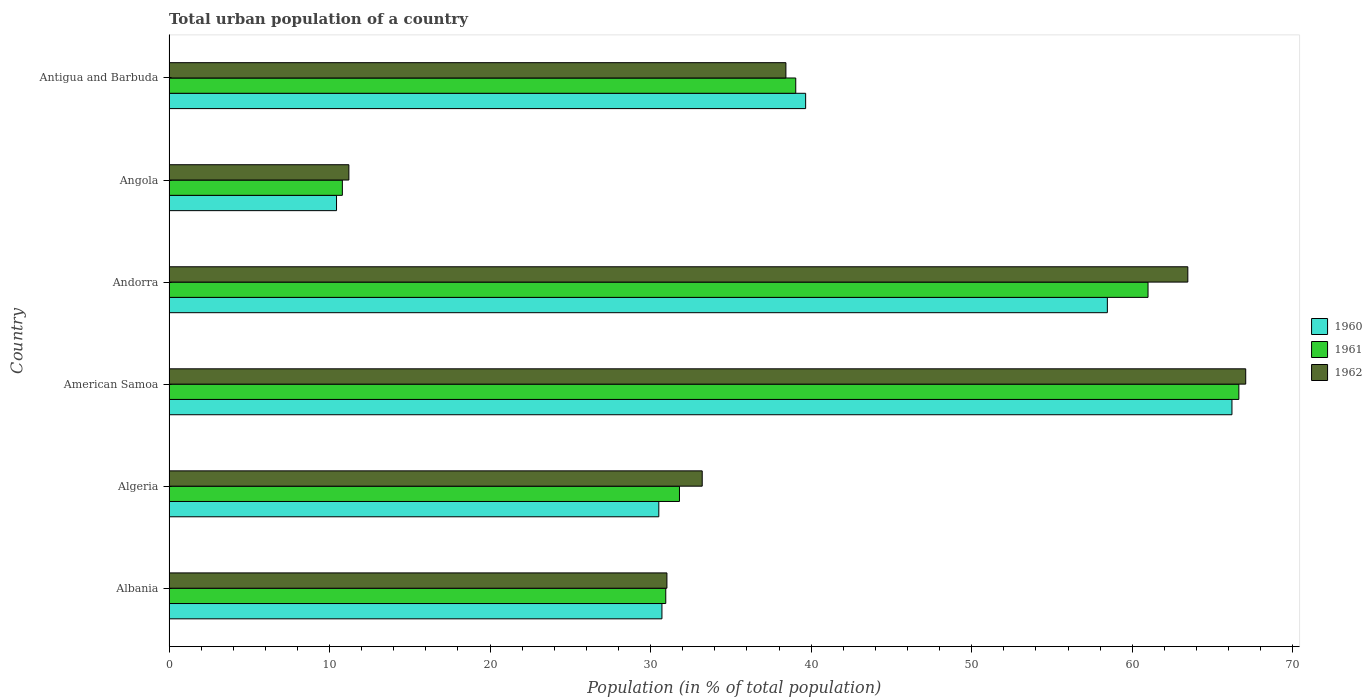How many groups of bars are there?
Provide a succinct answer. 6. Are the number of bars per tick equal to the number of legend labels?
Make the answer very short. Yes. Are the number of bars on each tick of the Y-axis equal?
Give a very brief answer. Yes. How many bars are there on the 6th tick from the top?
Keep it short and to the point. 3. How many bars are there on the 5th tick from the bottom?
Your answer should be very brief. 3. What is the label of the 6th group of bars from the top?
Give a very brief answer. Albania. What is the urban population in 1962 in Albania?
Offer a very short reply. 31.02. Across all countries, what is the maximum urban population in 1960?
Your answer should be compact. 66.21. Across all countries, what is the minimum urban population in 1960?
Offer a terse response. 10.44. In which country was the urban population in 1960 maximum?
Ensure brevity in your answer.  American Samoa. In which country was the urban population in 1962 minimum?
Give a very brief answer. Angola. What is the total urban population in 1961 in the graph?
Offer a very short reply. 240.2. What is the difference between the urban population in 1961 in Algeria and that in Andorra?
Give a very brief answer. -29.19. What is the difference between the urban population in 1960 in Antigua and Barbuda and the urban population in 1961 in Angola?
Make the answer very short. 28.86. What is the average urban population in 1962 per country?
Offer a very short reply. 40.73. What is the difference between the urban population in 1961 and urban population in 1960 in American Samoa?
Give a very brief answer. 0.43. In how many countries, is the urban population in 1960 greater than 54 %?
Your response must be concise. 2. What is the ratio of the urban population in 1960 in Albania to that in Andorra?
Make the answer very short. 0.53. What is the difference between the highest and the second highest urban population in 1962?
Your answer should be very brief. 3.61. What is the difference between the highest and the lowest urban population in 1960?
Make the answer very short. 55.78. In how many countries, is the urban population in 1962 greater than the average urban population in 1962 taken over all countries?
Provide a short and direct response. 2. What does the 1st bar from the bottom in American Samoa represents?
Give a very brief answer. 1960. How many countries are there in the graph?
Keep it short and to the point. 6. Does the graph contain grids?
Ensure brevity in your answer.  No. What is the title of the graph?
Give a very brief answer. Total urban population of a country. Does "1988" appear as one of the legend labels in the graph?
Offer a very short reply. No. What is the label or title of the X-axis?
Keep it short and to the point. Population (in % of total population). What is the Population (in % of total population) of 1960 in Albania?
Your response must be concise. 30.7. What is the Population (in % of total population) of 1961 in Albania?
Give a very brief answer. 30.94. What is the Population (in % of total population) of 1962 in Albania?
Provide a succinct answer. 31.02. What is the Population (in % of total population) in 1960 in Algeria?
Your response must be concise. 30.51. What is the Population (in % of total population) of 1961 in Algeria?
Offer a very short reply. 31.8. What is the Population (in % of total population) in 1962 in Algeria?
Your response must be concise. 33.21. What is the Population (in % of total population) of 1960 in American Samoa?
Your answer should be very brief. 66.21. What is the Population (in % of total population) of 1961 in American Samoa?
Offer a terse response. 66.64. What is the Population (in % of total population) in 1962 in American Samoa?
Provide a short and direct response. 67.07. What is the Population (in % of total population) in 1960 in Andorra?
Your response must be concise. 58.45. What is the Population (in % of total population) of 1961 in Andorra?
Your answer should be compact. 60.98. What is the Population (in % of total population) in 1962 in Andorra?
Give a very brief answer. 63.46. What is the Population (in % of total population) in 1960 in Angola?
Provide a short and direct response. 10.44. What is the Population (in % of total population) in 1961 in Angola?
Keep it short and to the point. 10.8. What is the Population (in % of total population) of 1962 in Angola?
Offer a terse response. 11.2. What is the Population (in % of total population) in 1960 in Antigua and Barbuda?
Your answer should be compact. 39.66. What is the Population (in % of total population) in 1961 in Antigua and Barbuda?
Give a very brief answer. 39.04. What is the Population (in % of total population) in 1962 in Antigua and Barbuda?
Provide a succinct answer. 38.43. Across all countries, what is the maximum Population (in % of total population) in 1960?
Provide a succinct answer. 66.21. Across all countries, what is the maximum Population (in % of total population) in 1961?
Keep it short and to the point. 66.64. Across all countries, what is the maximum Population (in % of total population) in 1962?
Provide a succinct answer. 67.07. Across all countries, what is the minimum Population (in % of total population) of 1960?
Your answer should be compact. 10.44. Across all countries, what is the minimum Population (in % of total population) in 1961?
Ensure brevity in your answer.  10.8. Across all countries, what is the minimum Population (in % of total population) in 1962?
Your answer should be compact. 11.2. What is the total Population (in % of total population) of 1960 in the graph?
Offer a terse response. 235.97. What is the total Population (in % of total population) of 1961 in the graph?
Your response must be concise. 240.2. What is the total Population (in % of total population) in 1962 in the graph?
Your response must be concise. 244.39. What is the difference between the Population (in % of total population) in 1960 in Albania and that in Algeria?
Offer a terse response. 0.2. What is the difference between the Population (in % of total population) in 1961 in Albania and that in Algeria?
Offer a terse response. -0.85. What is the difference between the Population (in % of total population) of 1962 in Albania and that in Algeria?
Give a very brief answer. -2.2. What is the difference between the Population (in % of total population) of 1960 in Albania and that in American Samoa?
Offer a terse response. -35.51. What is the difference between the Population (in % of total population) in 1961 in Albania and that in American Samoa?
Make the answer very short. -35.7. What is the difference between the Population (in % of total population) in 1962 in Albania and that in American Samoa?
Your answer should be compact. -36.05. What is the difference between the Population (in % of total population) of 1960 in Albania and that in Andorra?
Your answer should be very brief. -27.75. What is the difference between the Population (in % of total population) of 1961 in Albania and that in Andorra?
Provide a short and direct response. -30.04. What is the difference between the Population (in % of total population) of 1962 in Albania and that in Andorra?
Provide a short and direct response. -32.45. What is the difference between the Population (in % of total population) in 1960 in Albania and that in Angola?
Your answer should be compact. 20.27. What is the difference between the Population (in % of total population) in 1961 in Albania and that in Angola?
Give a very brief answer. 20.14. What is the difference between the Population (in % of total population) in 1962 in Albania and that in Angola?
Your answer should be very brief. 19.81. What is the difference between the Population (in % of total population) of 1960 in Albania and that in Antigua and Barbuda?
Offer a terse response. -8.95. What is the difference between the Population (in % of total population) of 1961 in Albania and that in Antigua and Barbuda?
Offer a very short reply. -8.1. What is the difference between the Population (in % of total population) of 1962 in Albania and that in Antigua and Barbuda?
Make the answer very short. -7.41. What is the difference between the Population (in % of total population) of 1960 in Algeria and that in American Samoa?
Make the answer very short. -35.7. What is the difference between the Population (in % of total population) in 1961 in Algeria and that in American Samoa?
Offer a very short reply. -34.84. What is the difference between the Population (in % of total population) of 1962 in Algeria and that in American Samoa?
Provide a short and direct response. -33.85. What is the difference between the Population (in % of total population) of 1960 in Algeria and that in Andorra?
Your response must be concise. -27.94. What is the difference between the Population (in % of total population) in 1961 in Algeria and that in Andorra?
Provide a succinct answer. -29.19. What is the difference between the Population (in % of total population) in 1962 in Algeria and that in Andorra?
Provide a short and direct response. -30.25. What is the difference between the Population (in % of total population) of 1960 in Algeria and that in Angola?
Offer a very short reply. 20.07. What is the difference between the Population (in % of total population) of 1961 in Algeria and that in Angola?
Offer a terse response. 21. What is the difference between the Population (in % of total population) of 1962 in Algeria and that in Angola?
Offer a terse response. 22.01. What is the difference between the Population (in % of total population) of 1960 in Algeria and that in Antigua and Barbuda?
Offer a very short reply. -9.15. What is the difference between the Population (in % of total population) of 1961 in Algeria and that in Antigua and Barbuda?
Give a very brief answer. -7.24. What is the difference between the Population (in % of total population) of 1962 in Algeria and that in Antigua and Barbuda?
Offer a very short reply. -5.21. What is the difference between the Population (in % of total population) in 1960 in American Samoa and that in Andorra?
Make the answer very short. 7.76. What is the difference between the Population (in % of total population) of 1961 in American Samoa and that in Andorra?
Offer a terse response. 5.66. What is the difference between the Population (in % of total population) in 1962 in American Samoa and that in Andorra?
Ensure brevity in your answer.  3.61. What is the difference between the Population (in % of total population) of 1960 in American Samoa and that in Angola?
Provide a succinct answer. 55.78. What is the difference between the Population (in % of total population) in 1961 in American Samoa and that in Angola?
Give a very brief answer. 55.84. What is the difference between the Population (in % of total population) of 1962 in American Samoa and that in Angola?
Your answer should be compact. 55.86. What is the difference between the Population (in % of total population) in 1960 in American Samoa and that in Antigua and Barbuda?
Keep it short and to the point. 26.55. What is the difference between the Population (in % of total population) of 1961 in American Samoa and that in Antigua and Barbuda?
Provide a short and direct response. 27.6. What is the difference between the Population (in % of total population) of 1962 in American Samoa and that in Antigua and Barbuda?
Offer a terse response. 28.64. What is the difference between the Population (in % of total population) of 1960 in Andorra and that in Angola?
Offer a very short reply. 48.02. What is the difference between the Population (in % of total population) of 1961 in Andorra and that in Angola?
Provide a short and direct response. 50.19. What is the difference between the Population (in % of total population) of 1962 in Andorra and that in Angola?
Give a very brief answer. 52.26. What is the difference between the Population (in % of total population) in 1960 in Andorra and that in Antigua and Barbuda?
Keep it short and to the point. 18.79. What is the difference between the Population (in % of total population) in 1961 in Andorra and that in Antigua and Barbuda?
Your answer should be very brief. 21.94. What is the difference between the Population (in % of total population) of 1962 in Andorra and that in Antigua and Barbuda?
Offer a terse response. 25.04. What is the difference between the Population (in % of total population) of 1960 in Angola and that in Antigua and Barbuda?
Keep it short and to the point. -29.22. What is the difference between the Population (in % of total population) in 1961 in Angola and that in Antigua and Barbuda?
Your response must be concise. -28.24. What is the difference between the Population (in % of total population) of 1962 in Angola and that in Antigua and Barbuda?
Ensure brevity in your answer.  -27.22. What is the difference between the Population (in % of total population) in 1960 in Albania and the Population (in % of total population) in 1961 in Algeria?
Give a very brief answer. -1.09. What is the difference between the Population (in % of total population) in 1960 in Albania and the Population (in % of total population) in 1962 in Algeria?
Your answer should be very brief. -2.51. What is the difference between the Population (in % of total population) of 1961 in Albania and the Population (in % of total population) of 1962 in Algeria?
Your answer should be very brief. -2.27. What is the difference between the Population (in % of total population) in 1960 in Albania and the Population (in % of total population) in 1961 in American Samoa?
Your answer should be compact. -35.94. What is the difference between the Population (in % of total population) in 1960 in Albania and the Population (in % of total population) in 1962 in American Samoa?
Provide a succinct answer. -36.36. What is the difference between the Population (in % of total population) in 1961 in Albania and the Population (in % of total population) in 1962 in American Samoa?
Provide a short and direct response. -36.12. What is the difference between the Population (in % of total population) of 1960 in Albania and the Population (in % of total population) of 1961 in Andorra?
Keep it short and to the point. -30.28. What is the difference between the Population (in % of total population) of 1960 in Albania and the Population (in % of total population) of 1962 in Andorra?
Provide a succinct answer. -32.76. What is the difference between the Population (in % of total population) in 1961 in Albania and the Population (in % of total population) in 1962 in Andorra?
Make the answer very short. -32.52. What is the difference between the Population (in % of total population) of 1960 in Albania and the Population (in % of total population) of 1961 in Angola?
Your response must be concise. 19.91. What is the difference between the Population (in % of total population) of 1960 in Albania and the Population (in % of total population) of 1962 in Angola?
Your answer should be very brief. 19.5. What is the difference between the Population (in % of total population) of 1961 in Albania and the Population (in % of total population) of 1962 in Angola?
Keep it short and to the point. 19.74. What is the difference between the Population (in % of total population) in 1960 in Albania and the Population (in % of total population) in 1961 in Antigua and Barbuda?
Keep it short and to the point. -8.34. What is the difference between the Population (in % of total population) of 1960 in Albania and the Population (in % of total population) of 1962 in Antigua and Barbuda?
Keep it short and to the point. -7.72. What is the difference between the Population (in % of total population) in 1961 in Albania and the Population (in % of total population) in 1962 in Antigua and Barbuda?
Provide a succinct answer. -7.48. What is the difference between the Population (in % of total population) of 1960 in Algeria and the Population (in % of total population) of 1961 in American Samoa?
Your answer should be very brief. -36.13. What is the difference between the Population (in % of total population) in 1960 in Algeria and the Population (in % of total population) in 1962 in American Samoa?
Provide a short and direct response. -36.56. What is the difference between the Population (in % of total population) of 1961 in Algeria and the Population (in % of total population) of 1962 in American Samoa?
Provide a succinct answer. -35.27. What is the difference between the Population (in % of total population) in 1960 in Algeria and the Population (in % of total population) in 1961 in Andorra?
Offer a very short reply. -30.47. What is the difference between the Population (in % of total population) in 1960 in Algeria and the Population (in % of total population) in 1962 in Andorra?
Keep it short and to the point. -32.95. What is the difference between the Population (in % of total population) in 1961 in Algeria and the Population (in % of total population) in 1962 in Andorra?
Your answer should be compact. -31.66. What is the difference between the Population (in % of total population) in 1960 in Algeria and the Population (in % of total population) in 1961 in Angola?
Provide a short and direct response. 19.71. What is the difference between the Population (in % of total population) of 1960 in Algeria and the Population (in % of total population) of 1962 in Angola?
Ensure brevity in your answer.  19.31. What is the difference between the Population (in % of total population) of 1961 in Algeria and the Population (in % of total population) of 1962 in Angola?
Offer a very short reply. 20.59. What is the difference between the Population (in % of total population) of 1960 in Algeria and the Population (in % of total population) of 1961 in Antigua and Barbuda?
Your answer should be compact. -8.53. What is the difference between the Population (in % of total population) of 1960 in Algeria and the Population (in % of total population) of 1962 in Antigua and Barbuda?
Keep it short and to the point. -7.92. What is the difference between the Population (in % of total population) of 1961 in Algeria and the Population (in % of total population) of 1962 in Antigua and Barbuda?
Provide a short and direct response. -6.63. What is the difference between the Population (in % of total population) of 1960 in American Samoa and the Population (in % of total population) of 1961 in Andorra?
Offer a very short reply. 5.23. What is the difference between the Population (in % of total population) in 1960 in American Samoa and the Population (in % of total population) in 1962 in Andorra?
Your response must be concise. 2.75. What is the difference between the Population (in % of total population) of 1961 in American Samoa and the Population (in % of total population) of 1962 in Andorra?
Your answer should be very brief. 3.18. What is the difference between the Population (in % of total population) of 1960 in American Samoa and the Population (in % of total population) of 1961 in Angola?
Offer a very short reply. 55.41. What is the difference between the Population (in % of total population) of 1960 in American Samoa and the Population (in % of total population) of 1962 in Angola?
Provide a short and direct response. 55.01. What is the difference between the Population (in % of total population) of 1961 in American Samoa and the Population (in % of total population) of 1962 in Angola?
Offer a very short reply. 55.44. What is the difference between the Population (in % of total population) in 1960 in American Samoa and the Population (in % of total population) in 1961 in Antigua and Barbuda?
Provide a short and direct response. 27.17. What is the difference between the Population (in % of total population) of 1960 in American Samoa and the Population (in % of total population) of 1962 in Antigua and Barbuda?
Offer a very short reply. 27.78. What is the difference between the Population (in % of total population) of 1961 in American Samoa and the Population (in % of total population) of 1962 in Antigua and Barbuda?
Give a very brief answer. 28.21. What is the difference between the Population (in % of total population) in 1960 in Andorra and the Population (in % of total population) in 1961 in Angola?
Give a very brief answer. 47.65. What is the difference between the Population (in % of total population) in 1960 in Andorra and the Population (in % of total population) in 1962 in Angola?
Ensure brevity in your answer.  47.25. What is the difference between the Population (in % of total population) in 1961 in Andorra and the Population (in % of total population) in 1962 in Angola?
Make the answer very short. 49.78. What is the difference between the Population (in % of total population) of 1960 in Andorra and the Population (in % of total population) of 1961 in Antigua and Barbuda?
Provide a short and direct response. 19.41. What is the difference between the Population (in % of total population) of 1960 in Andorra and the Population (in % of total population) of 1962 in Antigua and Barbuda?
Offer a terse response. 20.02. What is the difference between the Population (in % of total population) of 1961 in Andorra and the Population (in % of total population) of 1962 in Antigua and Barbuda?
Provide a short and direct response. 22.56. What is the difference between the Population (in % of total population) of 1960 in Angola and the Population (in % of total population) of 1961 in Antigua and Barbuda?
Your response must be concise. -28.61. What is the difference between the Population (in % of total population) of 1960 in Angola and the Population (in % of total population) of 1962 in Antigua and Barbuda?
Offer a very short reply. -27.99. What is the difference between the Population (in % of total population) of 1961 in Angola and the Population (in % of total population) of 1962 in Antigua and Barbuda?
Your answer should be compact. -27.63. What is the average Population (in % of total population) in 1960 per country?
Offer a terse response. 39.33. What is the average Population (in % of total population) of 1961 per country?
Provide a short and direct response. 40.03. What is the average Population (in % of total population) of 1962 per country?
Your answer should be very brief. 40.73. What is the difference between the Population (in % of total population) in 1960 and Population (in % of total population) in 1961 in Albania?
Make the answer very short. -0.24. What is the difference between the Population (in % of total population) of 1960 and Population (in % of total population) of 1962 in Albania?
Ensure brevity in your answer.  -0.31. What is the difference between the Population (in % of total population) of 1961 and Population (in % of total population) of 1962 in Albania?
Offer a terse response. -0.07. What is the difference between the Population (in % of total population) of 1960 and Population (in % of total population) of 1961 in Algeria?
Offer a very short reply. -1.29. What is the difference between the Population (in % of total population) in 1960 and Population (in % of total population) in 1962 in Algeria?
Give a very brief answer. -2.7. What is the difference between the Population (in % of total population) of 1961 and Population (in % of total population) of 1962 in Algeria?
Your response must be concise. -1.42. What is the difference between the Population (in % of total population) of 1960 and Population (in % of total population) of 1961 in American Samoa?
Your response must be concise. -0.43. What is the difference between the Population (in % of total population) in 1960 and Population (in % of total population) in 1962 in American Samoa?
Your answer should be very brief. -0.86. What is the difference between the Population (in % of total population) in 1961 and Population (in % of total population) in 1962 in American Samoa?
Ensure brevity in your answer.  -0.43. What is the difference between the Population (in % of total population) in 1960 and Population (in % of total population) in 1961 in Andorra?
Offer a terse response. -2.53. What is the difference between the Population (in % of total population) of 1960 and Population (in % of total population) of 1962 in Andorra?
Offer a very short reply. -5.01. What is the difference between the Population (in % of total population) in 1961 and Population (in % of total population) in 1962 in Andorra?
Your answer should be very brief. -2.48. What is the difference between the Population (in % of total population) in 1960 and Population (in % of total population) in 1961 in Angola?
Your answer should be very brief. -0.36. What is the difference between the Population (in % of total population) in 1960 and Population (in % of total population) in 1962 in Angola?
Your answer should be very brief. -0.77. What is the difference between the Population (in % of total population) of 1961 and Population (in % of total population) of 1962 in Angola?
Your answer should be very brief. -0.41. What is the difference between the Population (in % of total population) in 1960 and Population (in % of total population) in 1961 in Antigua and Barbuda?
Provide a succinct answer. 0.62. What is the difference between the Population (in % of total population) of 1960 and Population (in % of total population) of 1962 in Antigua and Barbuda?
Offer a terse response. 1.23. What is the difference between the Population (in % of total population) in 1961 and Population (in % of total population) in 1962 in Antigua and Barbuda?
Ensure brevity in your answer.  0.61. What is the ratio of the Population (in % of total population) of 1960 in Albania to that in Algeria?
Your answer should be compact. 1.01. What is the ratio of the Population (in % of total population) of 1961 in Albania to that in Algeria?
Keep it short and to the point. 0.97. What is the ratio of the Population (in % of total population) of 1962 in Albania to that in Algeria?
Keep it short and to the point. 0.93. What is the ratio of the Population (in % of total population) in 1960 in Albania to that in American Samoa?
Provide a succinct answer. 0.46. What is the ratio of the Population (in % of total population) of 1961 in Albania to that in American Samoa?
Keep it short and to the point. 0.46. What is the ratio of the Population (in % of total population) of 1962 in Albania to that in American Samoa?
Offer a very short reply. 0.46. What is the ratio of the Population (in % of total population) in 1960 in Albania to that in Andorra?
Your answer should be compact. 0.53. What is the ratio of the Population (in % of total population) in 1961 in Albania to that in Andorra?
Offer a very short reply. 0.51. What is the ratio of the Population (in % of total population) of 1962 in Albania to that in Andorra?
Offer a terse response. 0.49. What is the ratio of the Population (in % of total population) of 1960 in Albania to that in Angola?
Make the answer very short. 2.94. What is the ratio of the Population (in % of total population) of 1961 in Albania to that in Angola?
Offer a terse response. 2.87. What is the ratio of the Population (in % of total population) of 1962 in Albania to that in Angola?
Provide a short and direct response. 2.77. What is the ratio of the Population (in % of total population) in 1960 in Albania to that in Antigua and Barbuda?
Your answer should be compact. 0.77. What is the ratio of the Population (in % of total population) of 1961 in Albania to that in Antigua and Barbuda?
Your answer should be compact. 0.79. What is the ratio of the Population (in % of total population) of 1962 in Albania to that in Antigua and Barbuda?
Make the answer very short. 0.81. What is the ratio of the Population (in % of total population) in 1960 in Algeria to that in American Samoa?
Offer a terse response. 0.46. What is the ratio of the Population (in % of total population) of 1961 in Algeria to that in American Samoa?
Offer a terse response. 0.48. What is the ratio of the Population (in % of total population) in 1962 in Algeria to that in American Samoa?
Offer a very short reply. 0.5. What is the ratio of the Population (in % of total population) in 1960 in Algeria to that in Andorra?
Offer a very short reply. 0.52. What is the ratio of the Population (in % of total population) in 1961 in Algeria to that in Andorra?
Ensure brevity in your answer.  0.52. What is the ratio of the Population (in % of total population) of 1962 in Algeria to that in Andorra?
Give a very brief answer. 0.52. What is the ratio of the Population (in % of total population) in 1960 in Algeria to that in Angola?
Give a very brief answer. 2.92. What is the ratio of the Population (in % of total population) of 1961 in Algeria to that in Angola?
Make the answer very short. 2.94. What is the ratio of the Population (in % of total population) of 1962 in Algeria to that in Angola?
Offer a terse response. 2.96. What is the ratio of the Population (in % of total population) of 1960 in Algeria to that in Antigua and Barbuda?
Your answer should be very brief. 0.77. What is the ratio of the Population (in % of total population) of 1961 in Algeria to that in Antigua and Barbuda?
Keep it short and to the point. 0.81. What is the ratio of the Population (in % of total population) of 1962 in Algeria to that in Antigua and Barbuda?
Provide a succinct answer. 0.86. What is the ratio of the Population (in % of total population) of 1960 in American Samoa to that in Andorra?
Give a very brief answer. 1.13. What is the ratio of the Population (in % of total population) in 1961 in American Samoa to that in Andorra?
Make the answer very short. 1.09. What is the ratio of the Population (in % of total population) of 1962 in American Samoa to that in Andorra?
Ensure brevity in your answer.  1.06. What is the ratio of the Population (in % of total population) in 1960 in American Samoa to that in Angola?
Offer a very short reply. 6.35. What is the ratio of the Population (in % of total population) in 1961 in American Samoa to that in Angola?
Offer a very short reply. 6.17. What is the ratio of the Population (in % of total population) in 1962 in American Samoa to that in Angola?
Your answer should be very brief. 5.99. What is the ratio of the Population (in % of total population) of 1960 in American Samoa to that in Antigua and Barbuda?
Make the answer very short. 1.67. What is the ratio of the Population (in % of total population) in 1961 in American Samoa to that in Antigua and Barbuda?
Ensure brevity in your answer.  1.71. What is the ratio of the Population (in % of total population) in 1962 in American Samoa to that in Antigua and Barbuda?
Give a very brief answer. 1.75. What is the ratio of the Population (in % of total population) of 1960 in Andorra to that in Angola?
Give a very brief answer. 5.6. What is the ratio of the Population (in % of total population) of 1961 in Andorra to that in Angola?
Make the answer very short. 5.65. What is the ratio of the Population (in % of total population) in 1962 in Andorra to that in Angola?
Make the answer very short. 5.66. What is the ratio of the Population (in % of total population) of 1960 in Andorra to that in Antigua and Barbuda?
Your answer should be very brief. 1.47. What is the ratio of the Population (in % of total population) in 1961 in Andorra to that in Antigua and Barbuda?
Ensure brevity in your answer.  1.56. What is the ratio of the Population (in % of total population) in 1962 in Andorra to that in Antigua and Barbuda?
Make the answer very short. 1.65. What is the ratio of the Population (in % of total population) in 1960 in Angola to that in Antigua and Barbuda?
Make the answer very short. 0.26. What is the ratio of the Population (in % of total population) of 1961 in Angola to that in Antigua and Barbuda?
Provide a succinct answer. 0.28. What is the ratio of the Population (in % of total population) in 1962 in Angola to that in Antigua and Barbuda?
Make the answer very short. 0.29. What is the difference between the highest and the second highest Population (in % of total population) in 1960?
Provide a succinct answer. 7.76. What is the difference between the highest and the second highest Population (in % of total population) in 1961?
Your answer should be very brief. 5.66. What is the difference between the highest and the second highest Population (in % of total population) in 1962?
Your answer should be very brief. 3.61. What is the difference between the highest and the lowest Population (in % of total population) of 1960?
Your answer should be very brief. 55.78. What is the difference between the highest and the lowest Population (in % of total population) in 1961?
Keep it short and to the point. 55.84. What is the difference between the highest and the lowest Population (in % of total population) of 1962?
Your response must be concise. 55.86. 